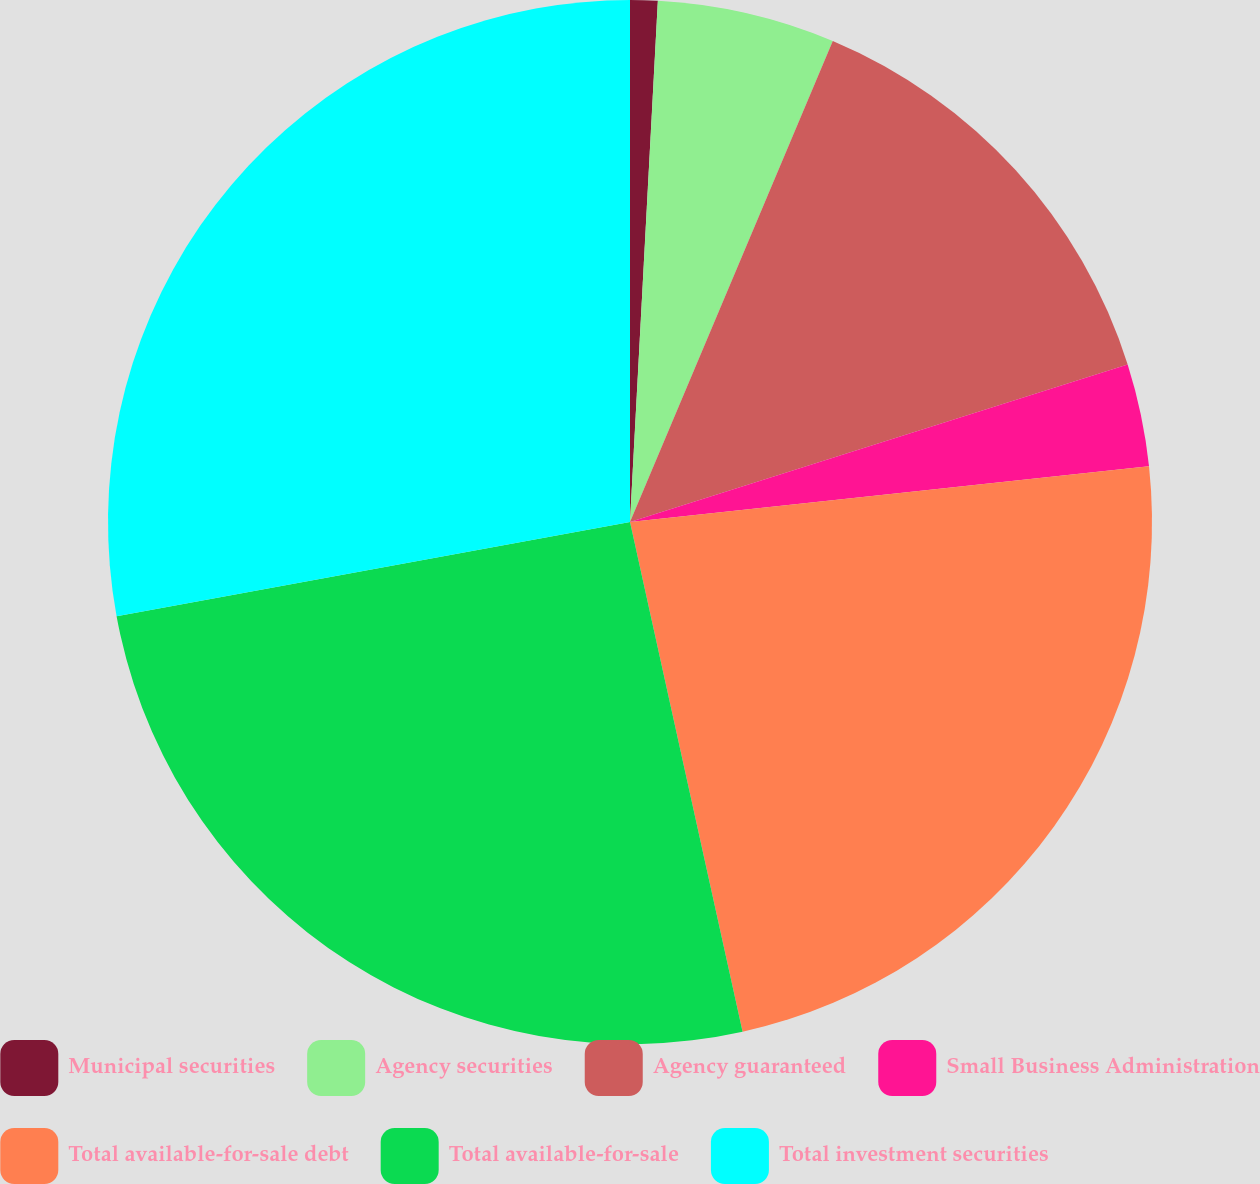Convert chart. <chart><loc_0><loc_0><loc_500><loc_500><pie_chart><fcel>Municipal securities<fcel>Agency securities<fcel>Agency guaranteed<fcel>Small Business Administration<fcel>Total available-for-sale debt<fcel>Total available-for-sale<fcel>Total investment securities<nl><fcel>0.85%<fcel>5.5%<fcel>13.77%<fcel>3.18%<fcel>23.24%<fcel>25.57%<fcel>27.89%<nl></chart> 